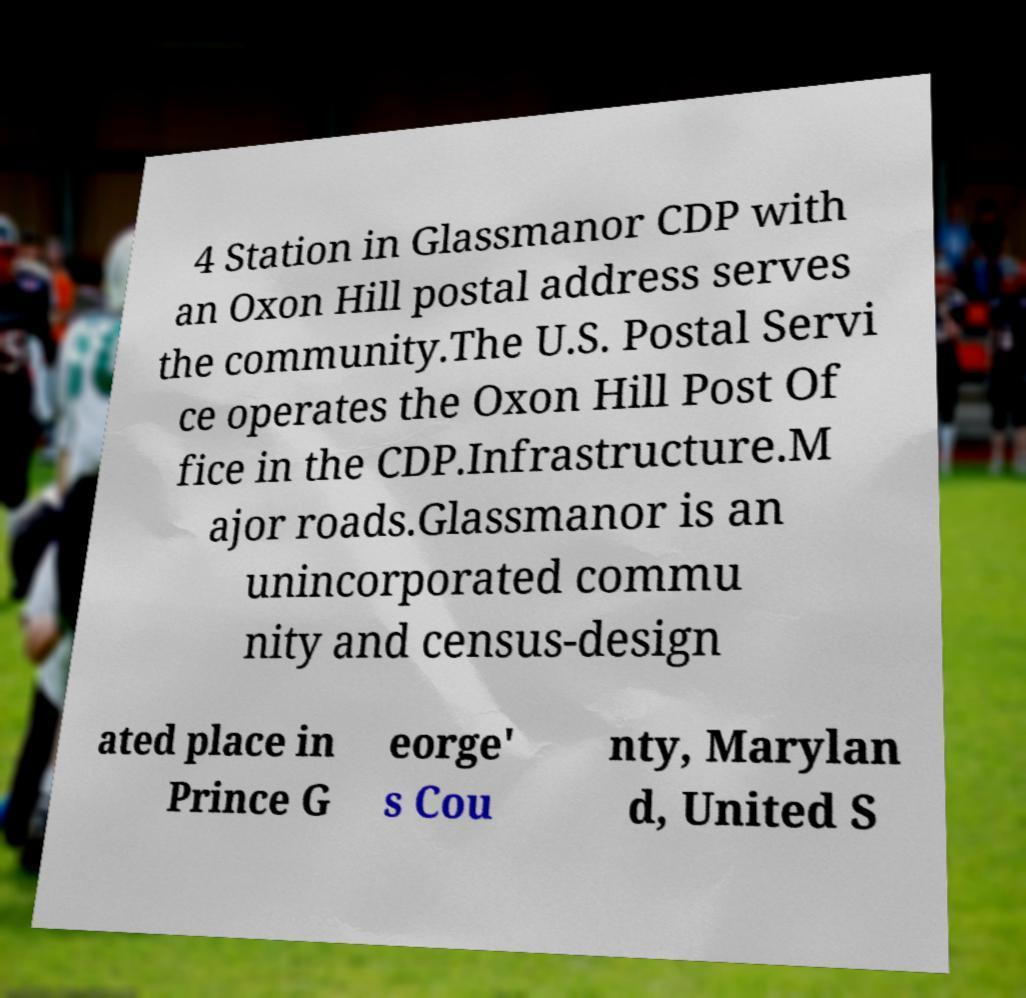There's text embedded in this image that I need extracted. Can you transcribe it verbatim? 4 Station in Glassmanor CDP with an Oxon Hill postal address serves the community.The U.S. Postal Servi ce operates the Oxon Hill Post Of fice in the CDP.Infrastructure.M ajor roads.Glassmanor is an unincorporated commu nity and census-design ated place in Prince G eorge' s Cou nty, Marylan d, United S 